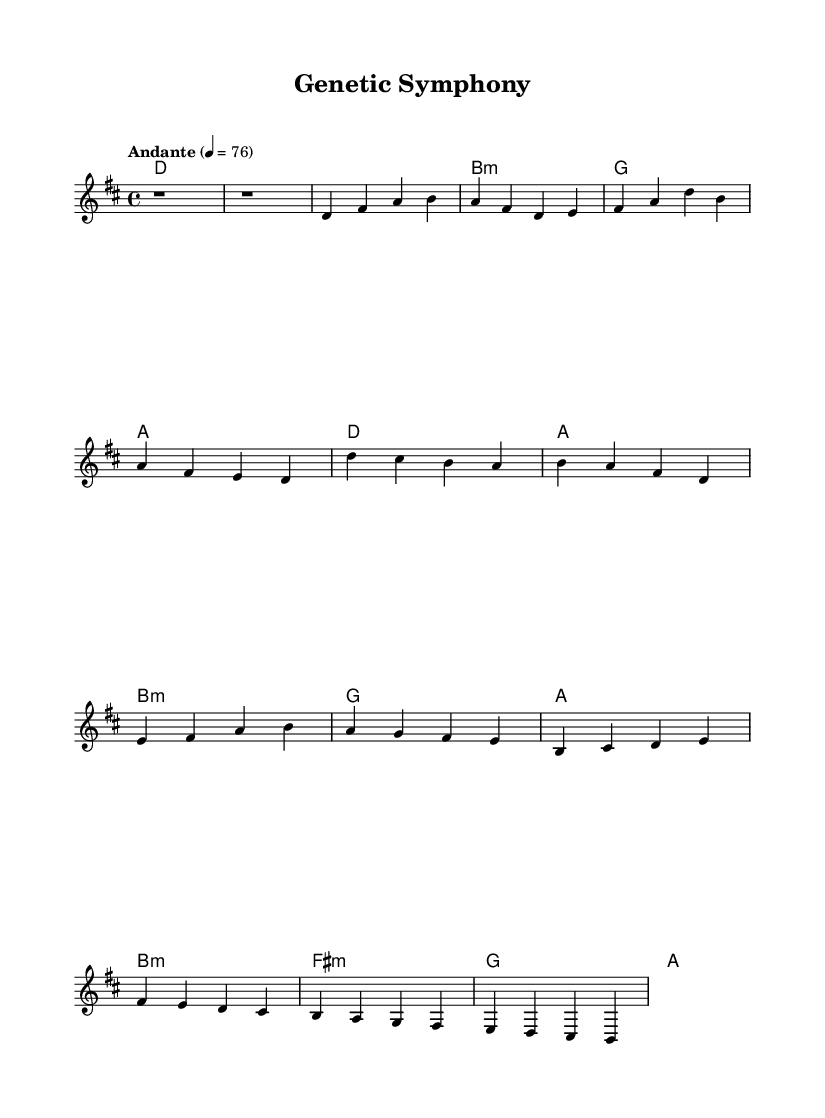What is the key signature of this music? The key signature is D major, which has two sharps (F# and C#).
Answer: D major What is the time signature of this music? The time signature is 4/4, indicating four beats in each measure.
Answer: 4/4 What is the tempo marking for this piece? The tempo marking is "Andante," which suggests a moderately slow tempo.
Answer: Andante What chords are used in the chorus section? The chorus features the chords D, A, B minor, and G.
Answer: D, A, B minor, G How many measures are there in the bridge section? The bridge section contains four measures as indicated by the division of the music into segments.
Answer: Four Which musical form is predominantly represented in this piece? The piece follows a verse-chorus structure, typical in K-Pop ballads.
Answer: Verse-chorus What is the final note of the melody in the bridge? The final note of the bridge melody is B, bringing a sense of resolution to that section.
Answer: B 